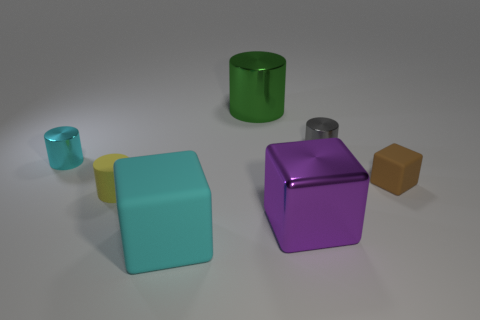Add 1 large blue things. How many objects exist? 8 Subtract all cylinders. How many objects are left? 3 Add 2 small metal objects. How many small metal objects are left? 4 Add 7 large purple things. How many large purple things exist? 8 Subtract 1 gray cylinders. How many objects are left? 6 Subtract all small shiny objects. Subtract all brown blocks. How many objects are left? 4 